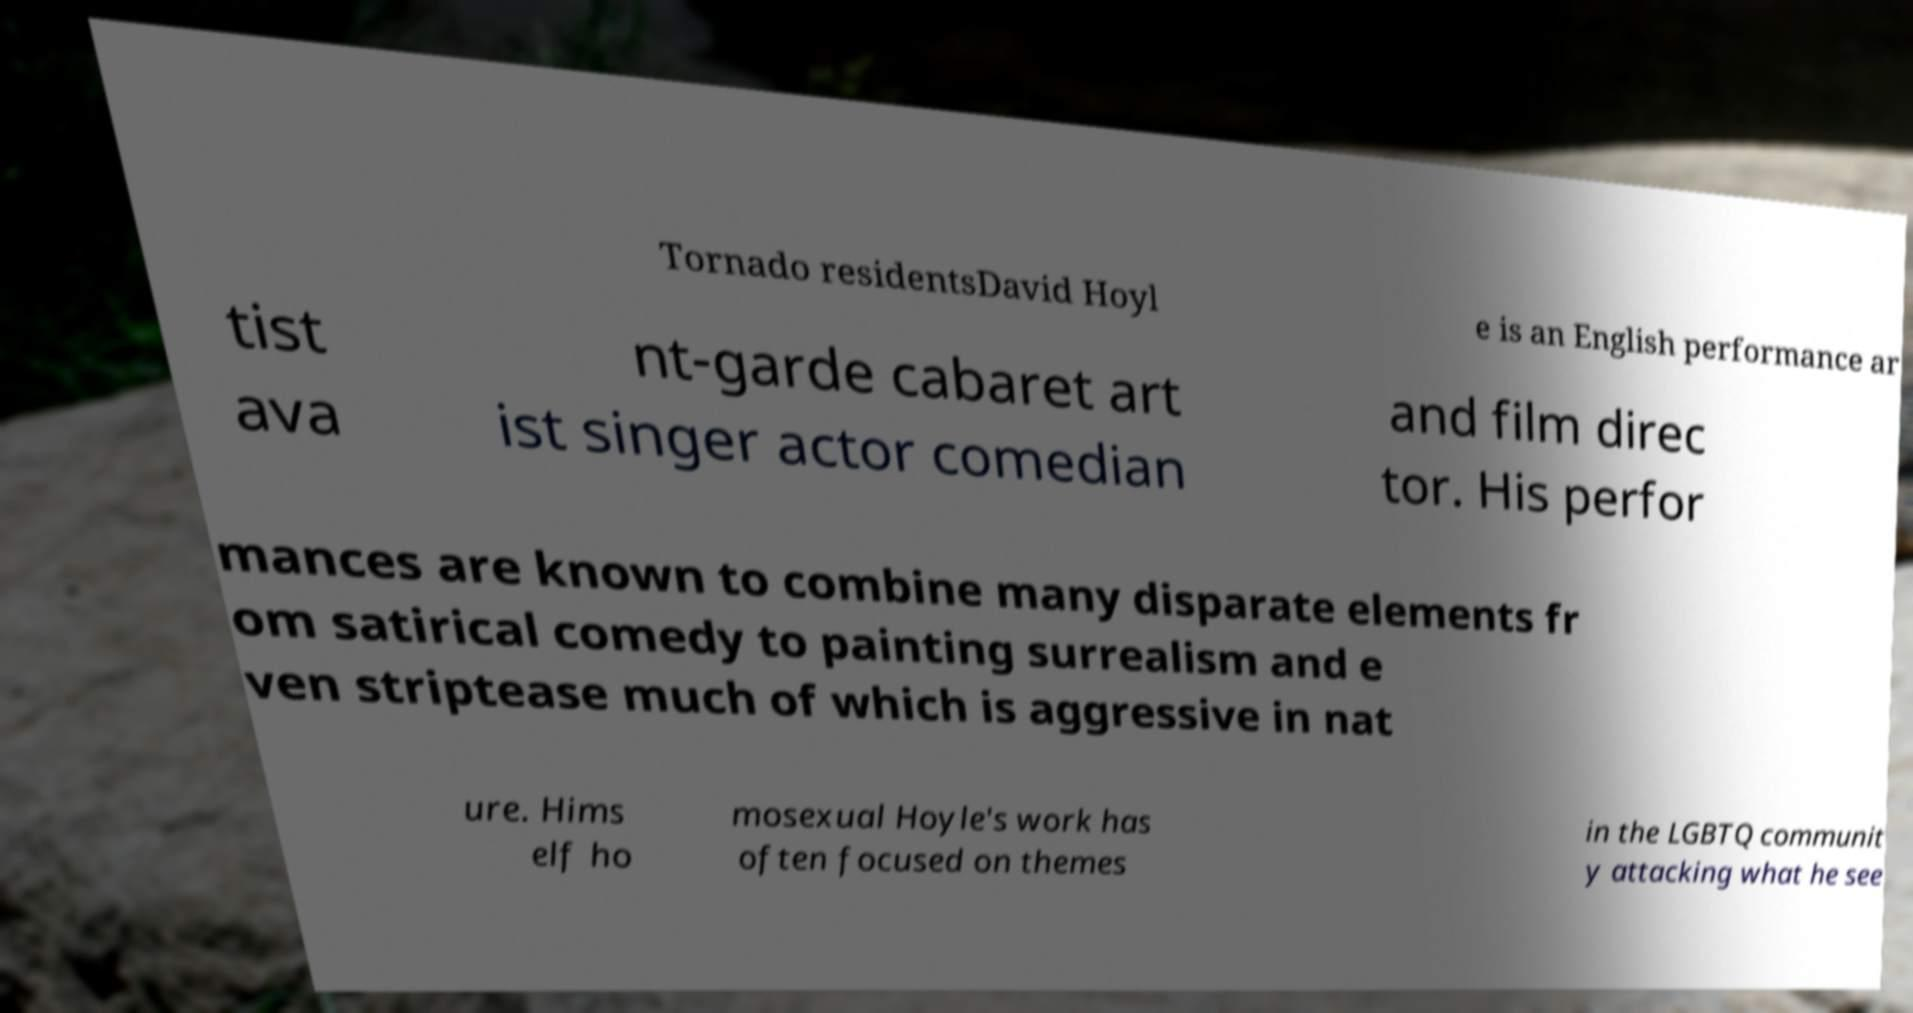Could you extract and type out the text from this image? Tornado residentsDavid Hoyl e is an English performance ar tist ava nt-garde cabaret art ist singer actor comedian and film direc tor. His perfor mances are known to combine many disparate elements fr om satirical comedy to painting surrealism and e ven striptease much of which is aggressive in nat ure. Hims elf ho mosexual Hoyle's work has often focused on themes in the LGBTQ communit y attacking what he see 